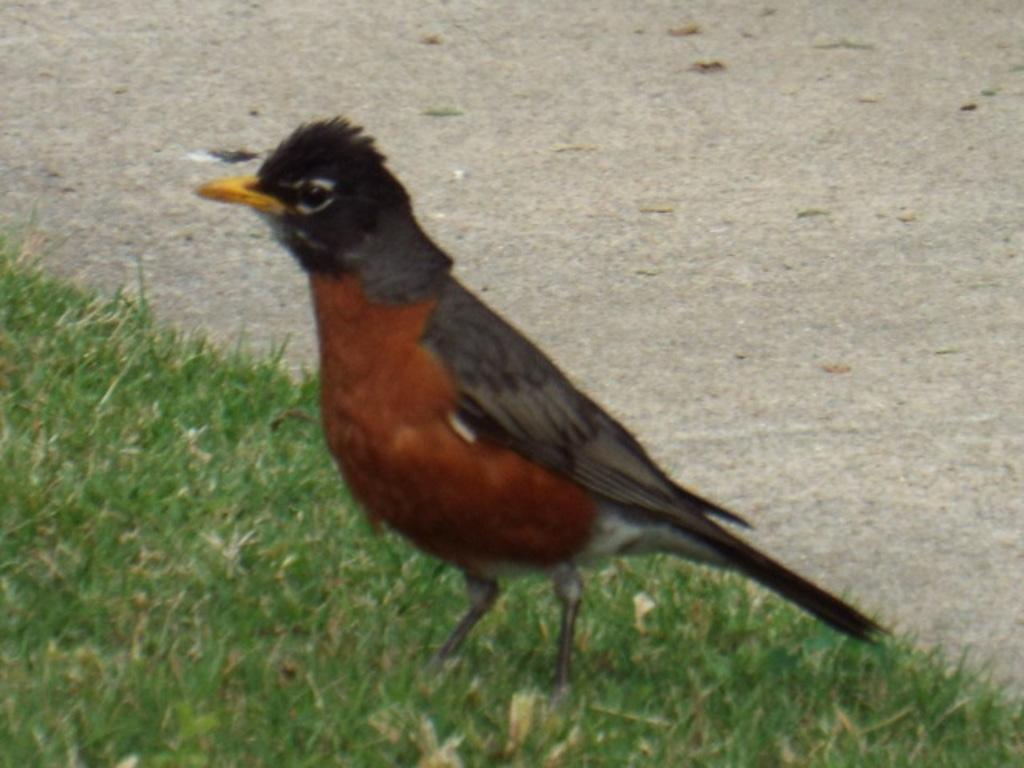What type of animal is in the image? There is a bird in the image. Where is the bird located in the image? The bird is on the ground. What type of library can be seen in the background of the image? There is no library present in the image; it only features a bird on the ground. 